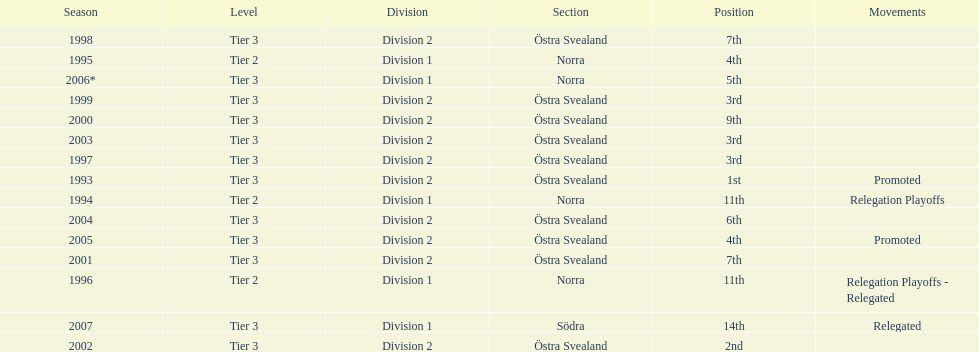In 2000 they finished 9th in their division, did they perform better or worse the next season? Better. 